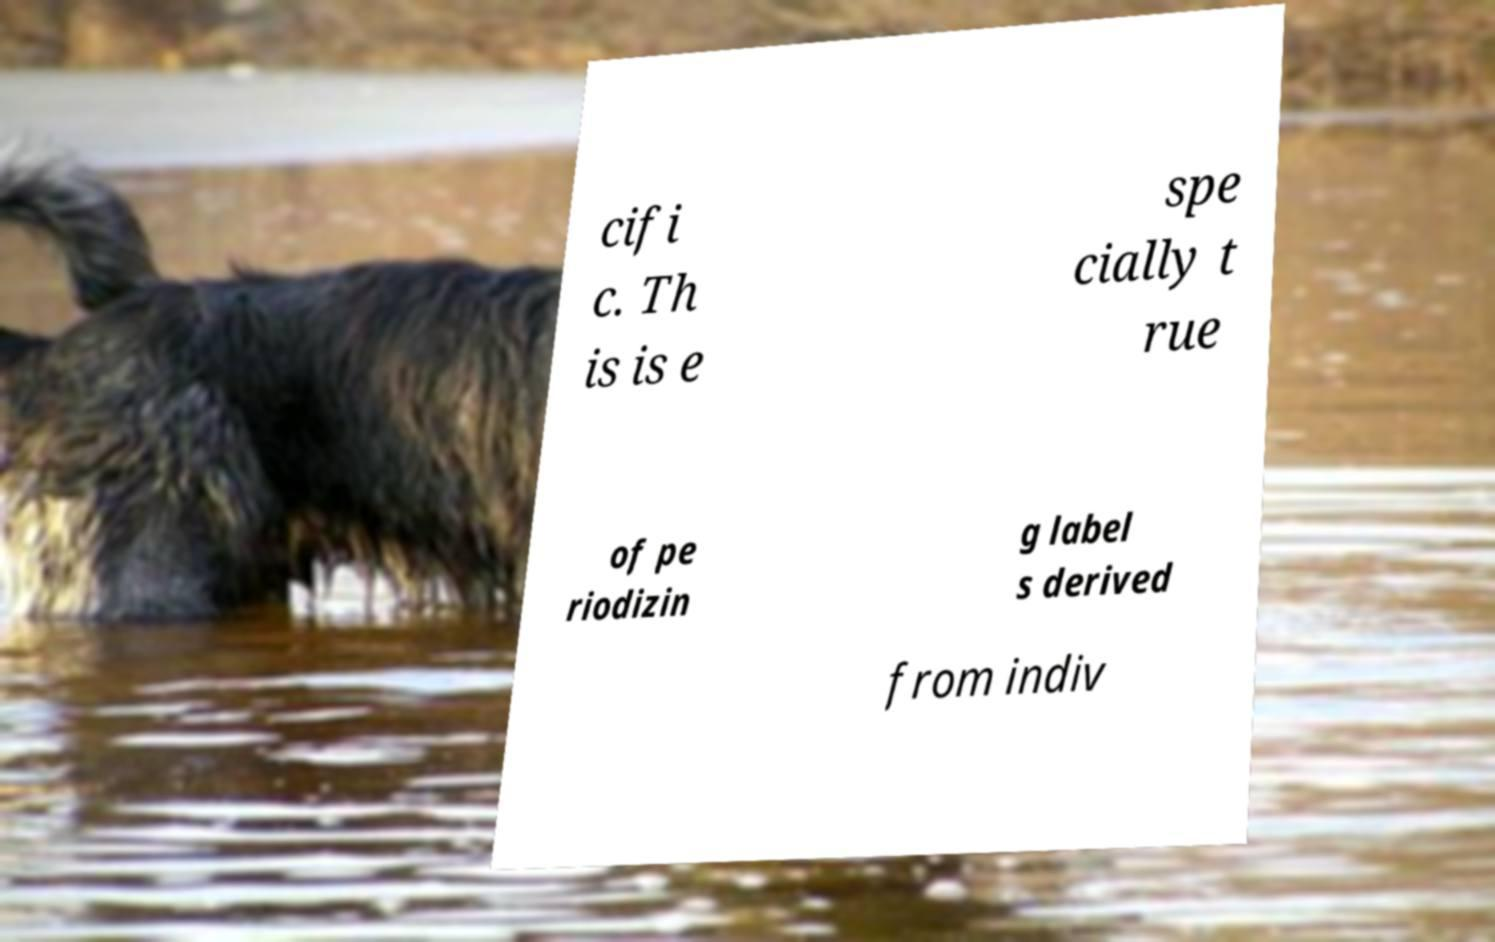Can you accurately transcribe the text from the provided image for me? cifi c. Th is is e spe cially t rue of pe riodizin g label s derived from indiv 